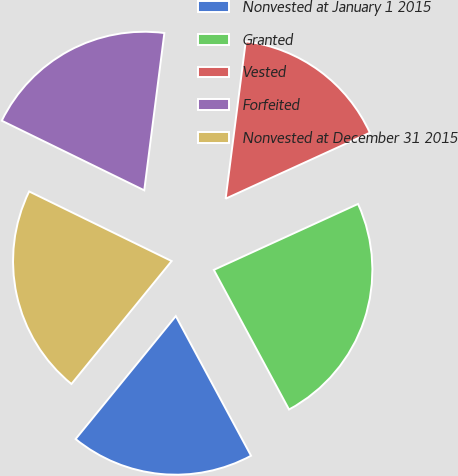Convert chart. <chart><loc_0><loc_0><loc_500><loc_500><pie_chart><fcel>Nonvested at January 1 2015<fcel>Granted<fcel>Vested<fcel>Forfeited<fcel>Nonvested at December 31 2015<nl><fcel>18.75%<fcel>23.96%<fcel>16.15%<fcel>19.79%<fcel>21.35%<nl></chart> 